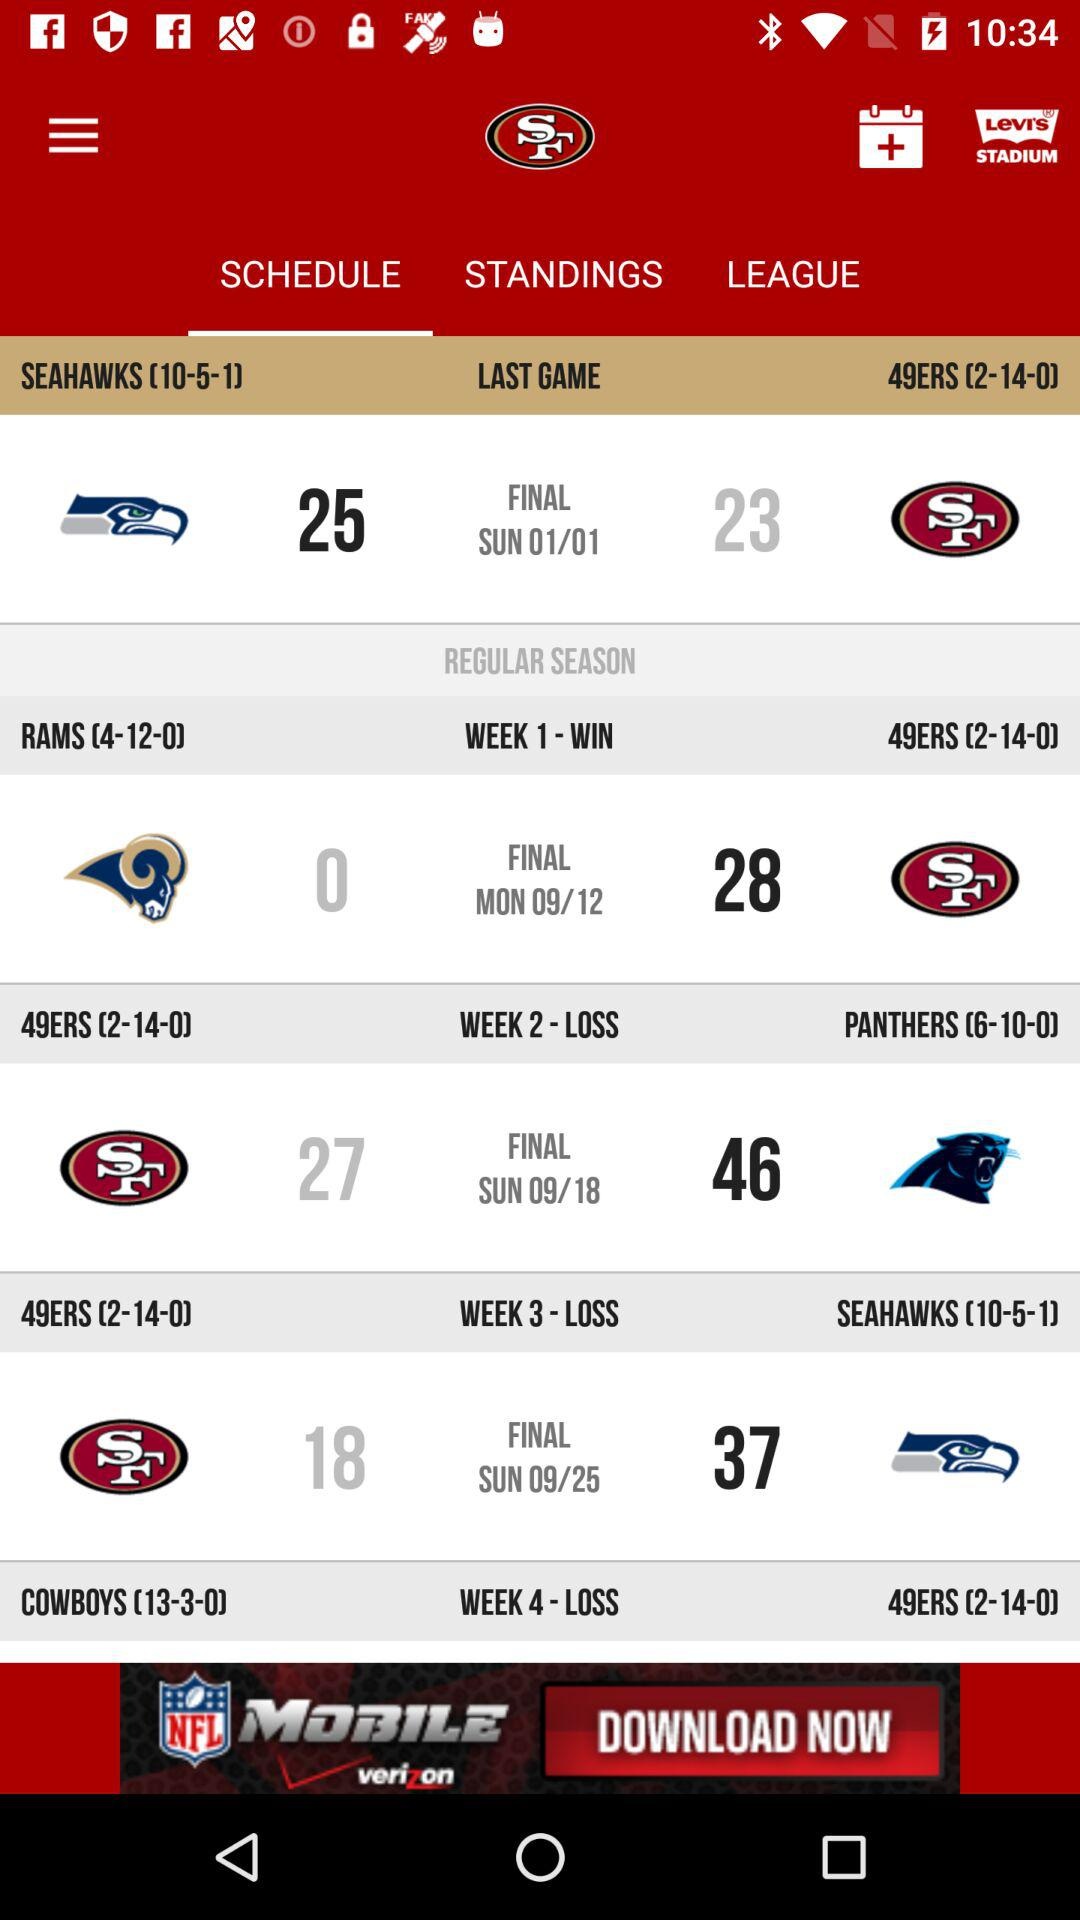What was the result of the match played in week 3? The result of the match played in week 3 was a loss. 